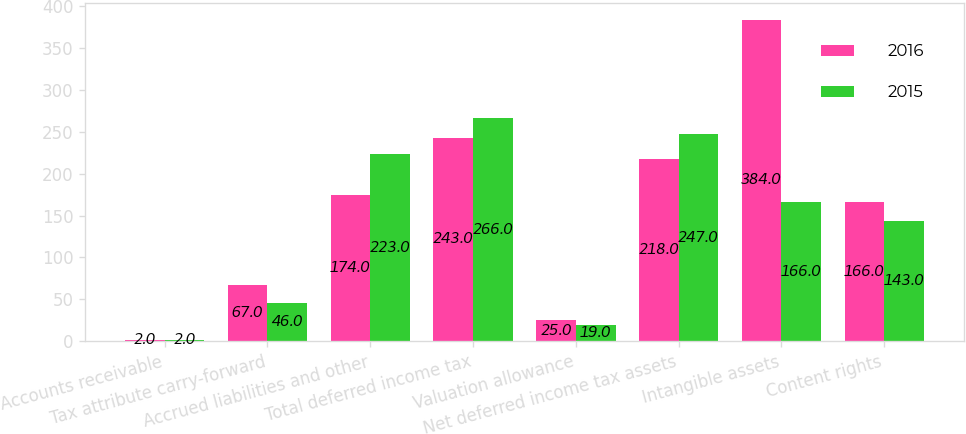<chart> <loc_0><loc_0><loc_500><loc_500><stacked_bar_chart><ecel><fcel>Accounts receivable<fcel>Tax attribute carry-forward<fcel>Accrued liabilities and other<fcel>Total deferred income tax<fcel>Valuation allowance<fcel>Net deferred income tax assets<fcel>Intangible assets<fcel>Content rights<nl><fcel>2016<fcel>2<fcel>67<fcel>174<fcel>243<fcel>25<fcel>218<fcel>384<fcel>166<nl><fcel>2015<fcel>2<fcel>46<fcel>223<fcel>266<fcel>19<fcel>247<fcel>166<fcel>143<nl></chart> 